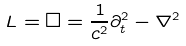Convert formula to latex. <formula><loc_0><loc_0><loc_500><loc_500>L = \square = { \frac { 1 } { c ^ { 2 } } } \partial _ { t } ^ { 2 } - \nabla ^ { 2 }</formula> 